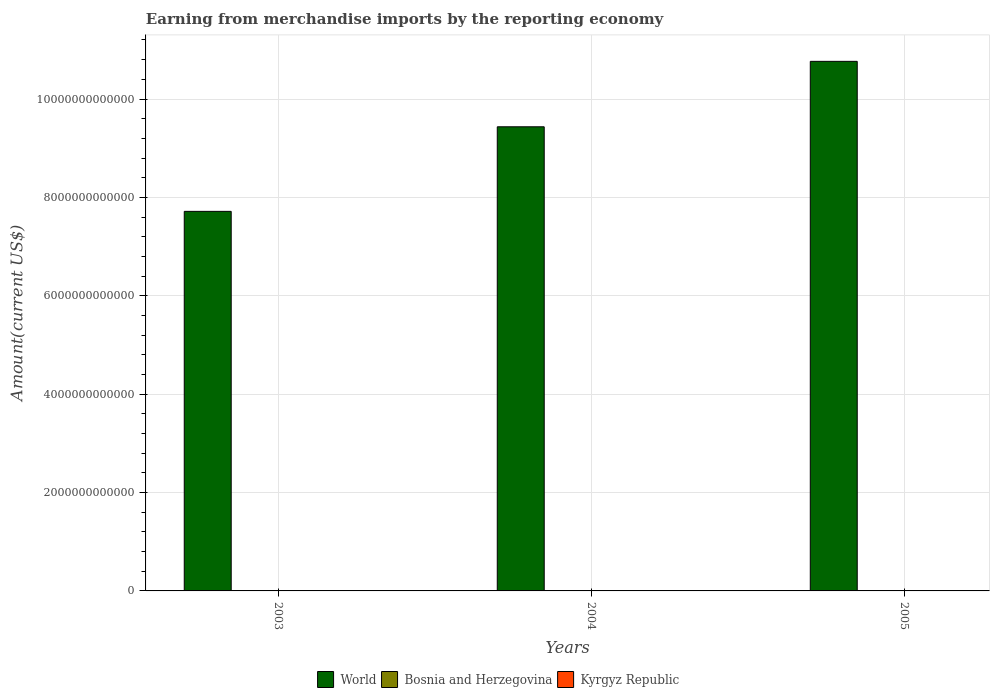Are the number of bars per tick equal to the number of legend labels?
Your answer should be compact. Yes. Are the number of bars on each tick of the X-axis equal?
Ensure brevity in your answer.  Yes. How many bars are there on the 1st tick from the right?
Offer a very short reply. 3. In how many cases, is the number of bars for a given year not equal to the number of legend labels?
Provide a short and direct response. 0. What is the amount earned from merchandise imports in Kyrgyz Republic in 2004?
Provide a short and direct response. 9.41e+08. Across all years, what is the maximum amount earned from merchandise imports in Bosnia and Herzegovina?
Ensure brevity in your answer.  5.75e+09. Across all years, what is the minimum amount earned from merchandise imports in Bosnia and Herzegovina?
Your answer should be compact. 4.00e+09. In which year was the amount earned from merchandise imports in World minimum?
Offer a terse response. 2003. What is the total amount earned from merchandise imports in Kyrgyz Republic in the graph?
Your answer should be very brief. 2.77e+09. What is the difference between the amount earned from merchandise imports in Kyrgyz Republic in 2003 and that in 2004?
Make the answer very short. -2.24e+08. What is the difference between the amount earned from merchandise imports in Bosnia and Herzegovina in 2005 and the amount earned from merchandise imports in Kyrgyz Republic in 2004?
Give a very brief answer. 4.81e+09. What is the average amount earned from merchandise imports in Bosnia and Herzegovina per year?
Make the answer very short. 4.89e+09. In the year 2005, what is the difference between the amount earned from merchandise imports in World and amount earned from merchandise imports in Kyrgyz Republic?
Your answer should be compact. 1.08e+13. What is the ratio of the amount earned from merchandise imports in Bosnia and Herzegovina in 2003 to that in 2005?
Make the answer very short. 0.7. Is the amount earned from merchandise imports in Bosnia and Herzegovina in 2003 less than that in 2005?
Offer a very short reply. Yes. What is the difference between the highest and the second highest amount earned from merchandise imports in Kyrgyz Republic?
Offer a very short reply. 1.71e+08. What is the difference between the highest and the lowest amount earned from merchandise imports in Kyrgyz Republic?
Make the answer very short. 3.95e+08. Is the sum of the amount earned from merchandise imports in Kyrgyz Republic in 2004 and 2005 greater than the maximum amount earned from merchandise imports in Bosnia and Herzegovina across all years?
Provide a short and direct response. No. What does the 3rd bar from the left in 2004 represents?
Provide a short and direct response. Kyrgyz Republic. What is the difference between two consecutive major ticks on the Y-axis?
Give a very brief answer. 2.00e+12. Does the graph contain grids?
Your answer should be compact. Yes. Where does the legend appear in the graph?
Provide a short and direct response. Bottom center. How many legend labels are there?
Offer a very short reply. 3. What is the title of the graph?
Offer a terse response. Earning from merchandise imports by the reporting economy. Does "Nepal" appear as one of the legend labels in the graph?
Your response must be concise. No. What is the label or title of the X-axis?
Your response must be concise. Years. What is the label or title of the Y-axis?
Your response must be concise. Amount(current US$). What is the Amount(current US$) of World in 2003?
Your answer should be compact. 7.72e+12. What is the Amount(current US$) of Bosnia and Herzegovina in 2003?
Offer a terse response. 4.00e+09. What is the Amount(current US$) of Kyrgyz Republic in 2003?
Provide a succinct answer. 7.17e+08. What is the Amount(current US$) of World in 2004?
Ensure brevity in your answer.  9.44e+12. What is the Amount(current US$) in Bosnia and Herzegovina in 2004?
Provide a short and direct response. 4.92e+09. What is the Amount(current US$) in Kyrgyz Republic in 2004?
Your response must be concise. 9.41e+08. What is the Amount(current US$) in World in 2005?
Give a very brief answer. 1.08e+13. What is the Amount(current US$) in Bosnia and Herzegovina in 2005?
Provide a succinct answer. 5.75e+09. What is the Amount(current US$) of Kyrgyz Republic in 2005?
Your answer should be compact. 1.11e+09. Across all years, what is the maximum Amount(current US$) in World?
Ensure brevity in your answer.  1.08e+13. Across all years, what is the maximum Amount(current US$) in Bosnia and Herzegovina?
Offer a very short reply. 5.75e+09. Across all years, what is the maximum Amount(current US$) of Kyrgyz Republic?
Provide a short and direct response. 1.11e+09. Across all years, what is the minimum Amount(current US$) of World?
Ensure brevity in your answer.  7.72e+12. Across all years, what is the minimum Amount(current US$) in Bosnia and Herzegovina?
Keep it short and to the point. 4.00e+09. Across all years, what is the minimum Amount(current US$) of Kyrgyz Republic?
Offer a very short reply. 7.17e+08. What is the total Amount(current US$) of World in the graph?
Your answer should be very brief. 2.79e+13. What is the total Amount(current US$) in Bosnia and Herzegovina in the graph?
Offer a terse response. 1.47e+1. What is the total Amount(current US$) of Kyrgyz Republic in the graph?
Your answer should be very brief. 2.77e+09. What is the difference between the Amount(current US$) in World in 2003 and that in 2004?
Your response must be concise. -1.72e+12. What is the difference between the Amount(current US$) in Bosnia and Herzegovina in 2003 and that in 2004?
Your answer should be very brief. -9.17e+08. What is the difference between the Amount(current US$) of Kyrgyz Republic in 2003 and that in 2004?
Make the answer very short. -2.24e+08. What is the difference between the Amount(current US$) of World in 2003 and that in 2005?
Provide a succinct answer. -3.05e+12. What is the difference between the Amount(current US$) in Bosnia and Herzegovina in 2003 and that in 2005?
Provide a short and direct response. -1.75e+09. What is the difference between the Amount(current US$) of Kyrgyz Republic in 2003 and that in 2005?
Provide a short and direct response. -3.95e+08. What is the difference between the Amount(current US$) in World in 2004 and that in 2005?
Give a very brief answer. -1.33e+12. What is the difference between the Amount(current US$) of Bosnia and Herzegovina in 2004 and that in 2005?
Offer a terse response. -8.36e+08. What is the difference between the Amount(current US$) of Kyrgyz Republic in 2004 and that in 2005?
Offer a very short reply. -1.71e+08. What is the difference between the Amount(current US$) of World in 2003 and the Amount(current US$) of Bosnia and Herzegovina in 2004?
Offer a very short reply. 7.71e+12. What is the difference between the Amount(current US$) of World in 2003 and the Amount(current US$) of Kyrgyz Republic in 2004?
Ensure brevity in your answer.  7.72e+12. What is the difference between the Amount(current US$) in Bosnia and Herzegovina in 2003 and the Amount(current US$) in Kyrgyz Republic in 2004?
Your answer should be compact. 3.06e+09. What is the difference between the Amount(current US$) of World in 2003 and the Amount(current US$) of Bosnia and Herzegovina in 2005?
Ensure brevity in your answer.  7.71e+12. What is the difference between the Amount(current US$) in World in 2003 and the Amount(current US$) in Kyrgyz Republic in 2005?
Keep it short and to the point. 7.72e+12. What is the difference between the Amount(current US$) of Bosnia and Herzegovina in 2003 and the Amount(current US$) of Kyrgyz Republic in 2005?
Give a very brief answer. 2.89e+09. What is the difference between the Amount(current US$) of World in 2004 and the Amount(current US$) of Bosnia and Herzegovina in 2005?
Make the answer very short. 9.43e+12. What is the difference between the Amount(current US$) of World in 2004 and the Amount(current US$) of Kyrgyz Republic in 2005?
Offer a very short reply. 9.43e+12. What is the difference between the Amount(current US$) of Bosnia and Herzegovina in 2004 and the Amount(current US$) of Kyrgyz Republic in 2005?
Give a very brief answer. 3.81e+09. What is the average Amount(current US$) in World per year?
Offer a terse response. 9.31e+12. What is the average Amount(current US$) of Bosnia and Herzegovina per year?
Your response must be concise. 4.89e+09. What is the average Amount(current US$) in Kyrgyz Republic per year?
Offer a terse response. 9.23e+08. In the year 2003, what is the difference between the Amount(current US$) in World and Amount(current US$) in Bosnia and Herzegovina?
Offer a very short reply. 7.71e+12. In the year 2003, what is the difference between the Amount(current US$) of World and Amount(current US$) of Kyrgyz Republic?
Ensure brevity in your answer.  7.72e+12. In the year 2003, what is the difference between the Amount(current US$) of Bosnia and Herzegovina and Amount(current US$) of Kyrgyz Republic?
Give a very brief answer. 3.28e+09. In the year 2004, what is the difference between the Amount(current US$) of World and Amount(current US$) of Bosnia and Herzegovina?
Give a very brief answer. 9.43e+12. In the year 2004, what is the difference between the Amount(current US$) of World and Amount(current US$) of Kyrgyz Republic?
Give a very brief answer. 9.43e+12. In the year 2004, what is the difference between the Amount(current US$) of Bosnia and Herzegovina and Amount(current US$) of Kyrgyz Republic?
Keep it short and to the point. 3.98e+09. In the year 2005, what is the difference between the Amount(current US$) of World and Amount(current US$) of Bosnia and Herzegovina?
Make the answer very short. 1.08e+13. In the year 2005, what is the difference between the Amount(current US$) of World and Amount(current US$) of Kyrgyz Republic?
Provide a succinct answer. 1.08e+13. In the year 2005, what is the difference between the Amount(current US$) of Bosnia and Herzegovina and Amount(current US$) of Kyrgyz Republic?
Offer a very short reply. 4.64e+09. What is the ratio of the Amount(current US$) in World in 2003 to that in 2004?
Offer a terse response. 0.82. What is the ratio of the Amount(current US$) in Bosnia and Herzegovina in 2003 to that in 2004?
Offer a terse response. 0.81. What is the ratio of the Amount(current US$) in Kyrgyz Republic in 2003 to that in 2004?
Provide a short and direct response. 0.76. What is the ratio of the Amount(current US$) in World in 2003 to that in 2005?
Provide a succinct answer. 0.72. What is the ratio of the Amount(current US$) in Bosnia and Herzegovina in 2003 to that in 2005?
Your response must be concise. 0.7. What is the ratio of the Amount(current US$) in Kyrgyz Republic in 2003 to that in 2005?
Ensure brevity in your answer.  0.65. What is the ratio of the Amount(current US$) in World in 2004 to that in 2005?
Make the answer very short. 0.88. What is the ratio of the Amount(current US$) of Bosnia and Herzegovina in 2004 to that in 2005?
Your answer should be compact. 0.85. What is the ratio of the Amount(current US$) of Kyrgyz Republic in 2004 to that in 2005?
Make the answer very short. 0.85. What is the difference between the highest and the second highest Amount(current US$) in World?
Offer a very short reply. 1.33e+12. What is the difference between the highest and the second highest Amount(current US$) in Bosnia and Herzegovina?
Your answer should be very brief. 8.36e+08. What is the difference between the highest and the second highest Amount(current US$) of Kyrgyz Republic?
Your answer should be very brief. 1.71e+08. What is the difference between the highest and the lowest Amount(current US$) of World?
Offer a terse response. 3.05e+12. What is the difference between the highest and the lowest Amount(current US$) in Bosnia and Herzegovina?
Keep it short and to the point. 1.75e+09. What is the difference between the highest and the lowest Amount(current US$) in Kyrgyz Republic?
Offer a very short reply. 3.95e+08. 